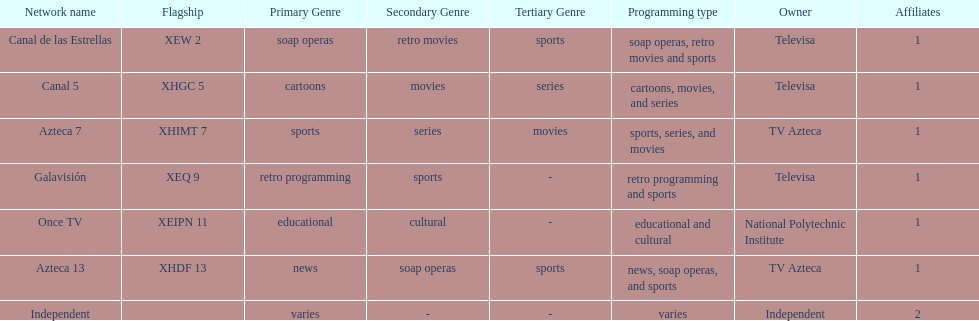How many networks do not air sports? 2. 